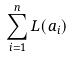Convert formula to latex. <formula><loc_0><loc_0><loc_500><loc_500>\sum _ { i = 1 } ^ { n } L ( a _ { i } )</formula> 